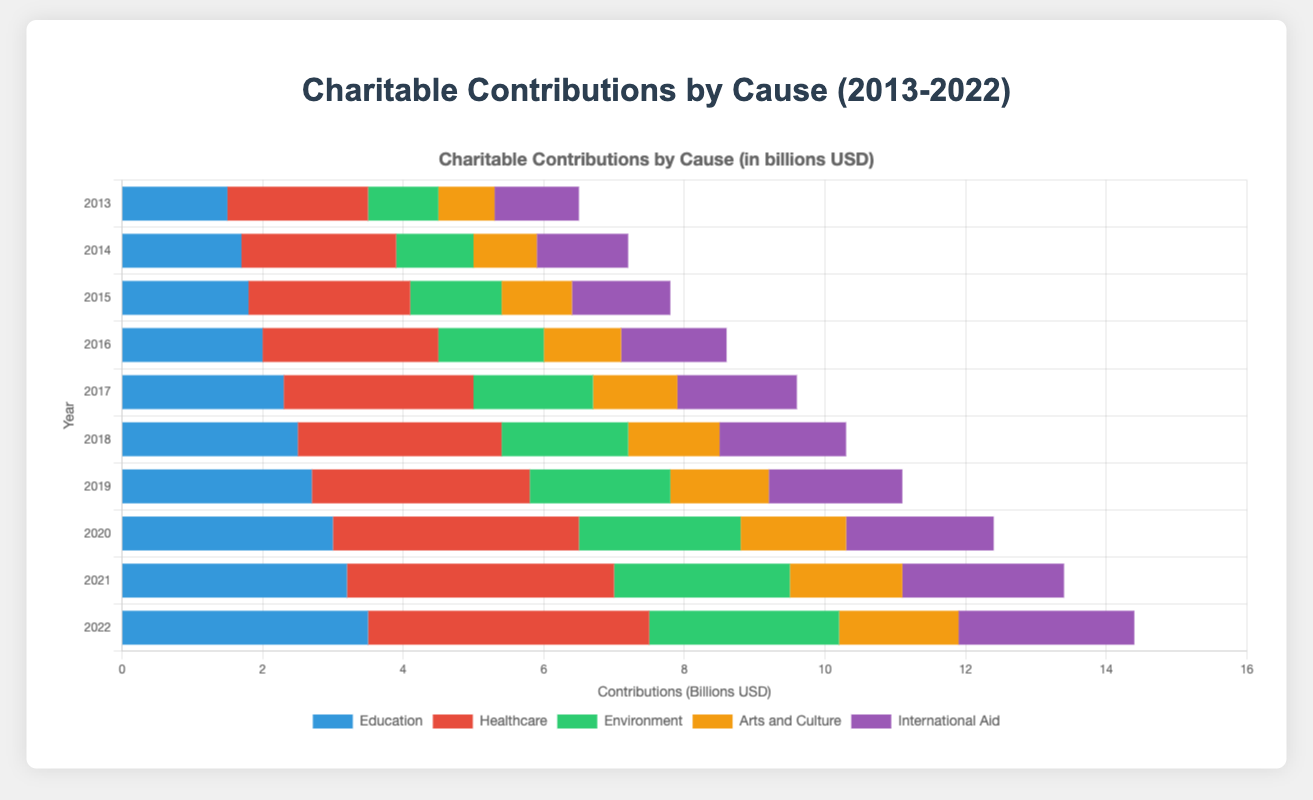Which cause has received the highest donations in 2022? The bar representing Healthcare is the longest in 2022, indicating it received the highest contributions.
Answer: Healthcare Which cause shows the most growth in donations from 2013 to 2022? To find which cause has grown the most, subtract the 2013 value from the 2022 value for each cause: Education (3.5-1.5), Healthcare (4.0-2.0), Environment (2.7-1.0), Arts and Culture (1.7-0.8), International Aid (2.5-1.2). Healthcare shows the most growth.
Answer: Healthcare What is the total amount donated to Environment causes over the entire decade? Add the contributions for the Environment from 2013 to 2022: 1+1.1+1.3+1.5+1.7+1.8+2+2.3+2.5+2.7 = 17.9 billion USD.
Answer: 17.9 billion USD How did donations to Arts and Culture change from 2015 to 2021? Compare the values in 2015 and 2021. Donations increased from 1.0 billion in 2015 to 1.6 billion in 2021.
Answer: Increased by 0.6 billion USD Which year had the smallest total donations across all causes? Sum the donations for each year and compare them: 2013: 6.5, 2014: 7.2, 2015: 7.8, 2016: 8.6, 2017: 9.6, 2018: 10.3, 2019: 11.1, 2020: 12.4, 2021: 13.4, 2022: 14.4. The smallest total is in 2013.
Answer: 2013 By how much did contributions to International Aid increase between 2014 and 2020? Subtract the 2014 value from the 2020 value: 2.1 - 1.3 = 0.8 billion USD.
Answer: 0.8 billion USD What is the average annual donation to Healthcare over the decade? Sum all Healthcare donations and divide by the number of years: (2+2.2+2.3+2.5+2.7+2.9+3.1+3.5+3.8+4.0)/10 = 2.9 billion USD.
Answer: 2.9 billion USD Which cause received the least contributions in 2019? The shortest bar in 2019 is Arts and Culture with 1.4 billion USD.
Answer: Arts and Culture 